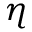Convert formula to latex. <formula><loc_0><loc_0><loc_500><loc_500>\eta</formula> 